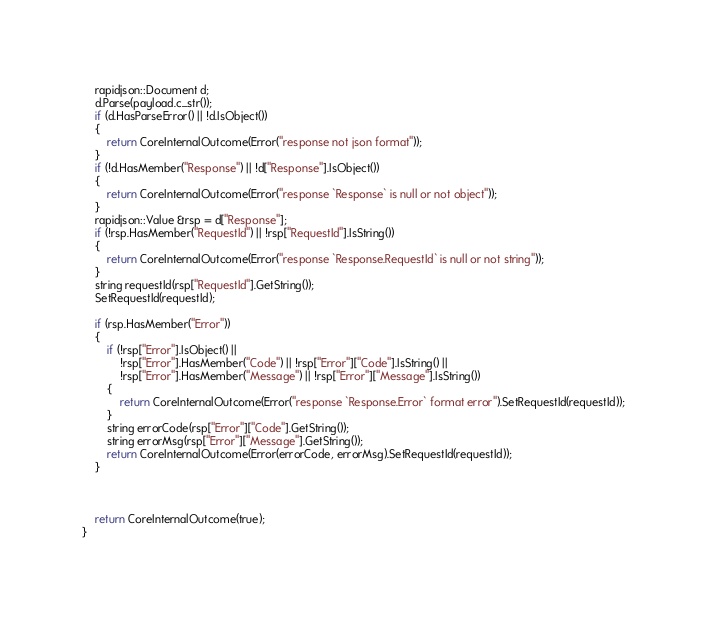Convert code to text. <code><loc_0><loc_0><loc_500><loc_500><_C++_>    rapidjson::Document d;
    d.Parse(payload.c_str());
    if (d.HasParseError() || !d.IsObject())
    {
        return CoreInternalOutcome(Error("response not json format"));
    }
    if (!d.HasMember("Response") || !d["Response"].IsObject())
    {
        return CoreInternalOutcome(Error("response `Response` is null or not object"));
    }
    rapidjson::Value &rsp = d["Response"];
    if (!rsp.HasMember("RequestId") || !rsp["RequestId"].IsString())
    {
        return CoreInternalOutcome(Error("response `Response.RequestId` is null or not string"));
    }
    string requestId(rsp["RequestId"].GetString());
    SetRequestId(requestId);

    if (rsp.HasMember("Error"))
    {
        if (!rsp["Error"].IsObject() ||
            !rsp["Error"].HasMember("Code") || !rsp["Error"]["Code"].IsString() ||
            !rsp["Error"].HasMember("Message") || !rsp["Error"]["Message"].IsString())
        {
            return CoreInternalOutcome(Error("response `Response.Error` format error").SetRequestId(requestId));
        }
        string errorCode(rsp["Error"]["Code"].GetString());
        string errorMsg(rsp["Error"]["Message"].GetString());
        return CoreInternalOutcome(Error(errorCode, errorMsg).SetRequestId(requestId));
    }



    return CoreInternalOutcome(true);
}



</code> 